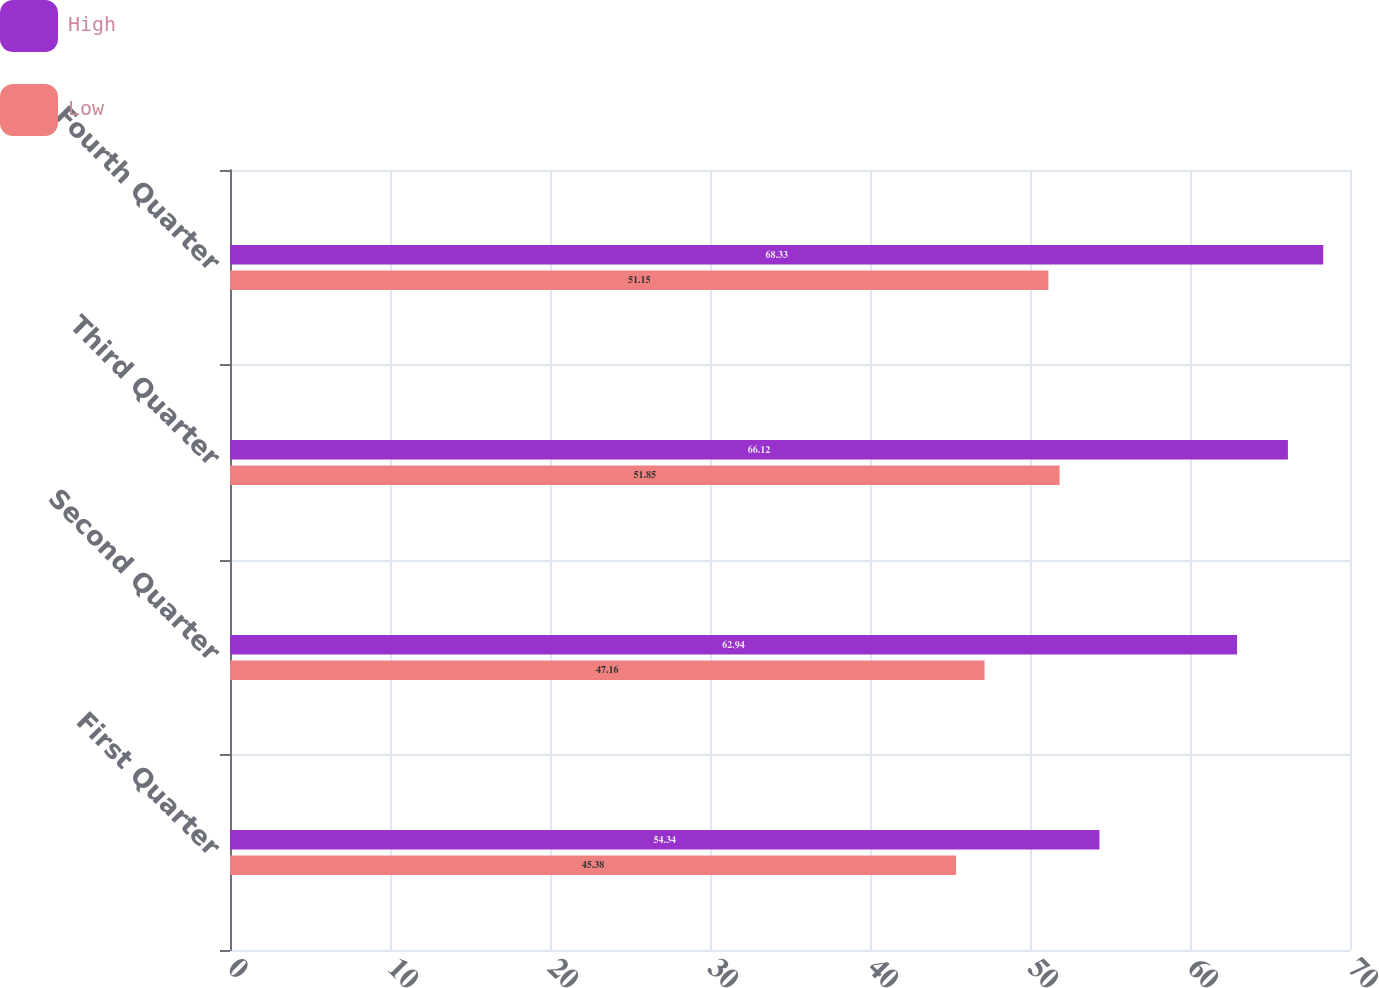<chart> <loc_0><loc_0><loc_500><loc_500><stacked_bar_chart><ecel><fcel>First Quarter<fcel>Second Quarter<fcel>Third Quarter<fcel>Fourth Quarter<nl><fcel>High<fcel>54.34<fcel>62.94<fcel>66.12<fcel>68.33<nl><fcel>Low<fcel>45.38<fcel>47.16<fcel>51.85<fcel>51.15<nl></chart> 